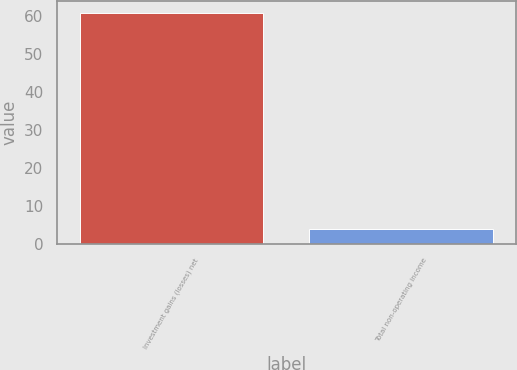Convert chart to OTSL. <chart><loc_0><loc_0><loc_500><loc_500><bar_chart><fcel>Investment gains (losses) net<fcel>Total non-operating income<nl><fcel>61<fcel>4<nl></chart> 